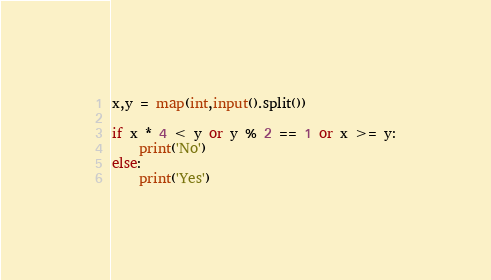Convert code to text. <code><loc_0><loc_0><loc_500><loc_500><_Python_>x,y = map(int,input().split())

if x * 4 < y or y % 2 == 1 or x >= y:
    print('No')
else:
    print('Yes')
</code> 